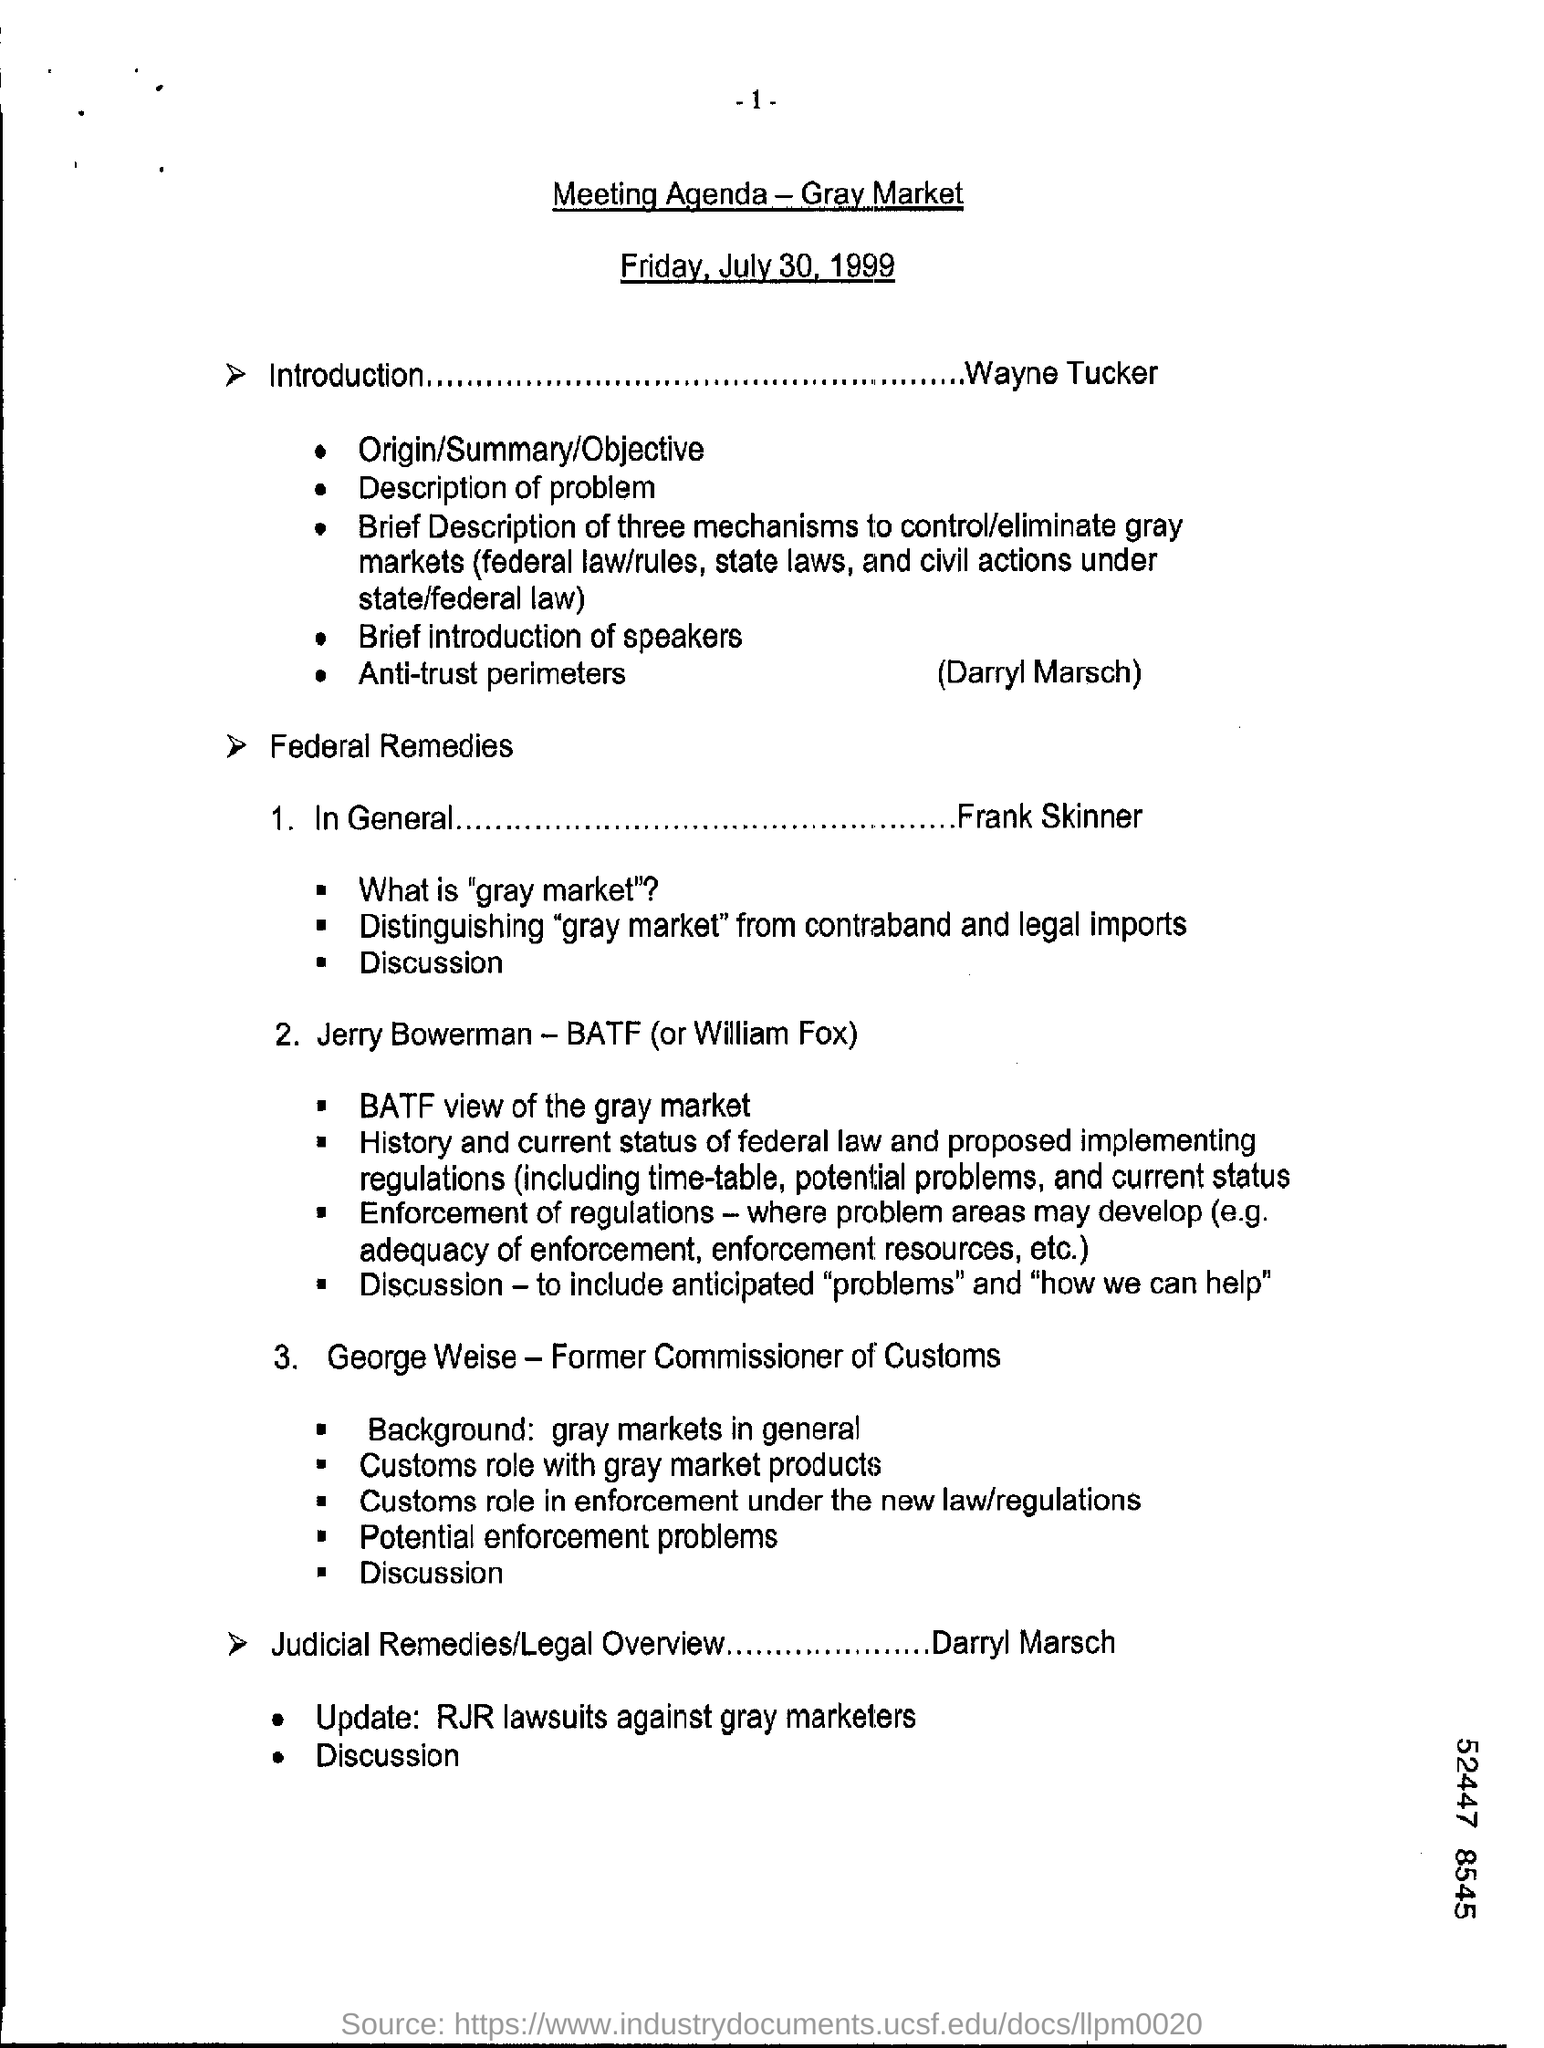What is the title?
Your answer should be very brief. Meeting agenda - gray market. What is the date mentioned in this document?
Provide a short and direct response. Friday, July 30, 1999. 